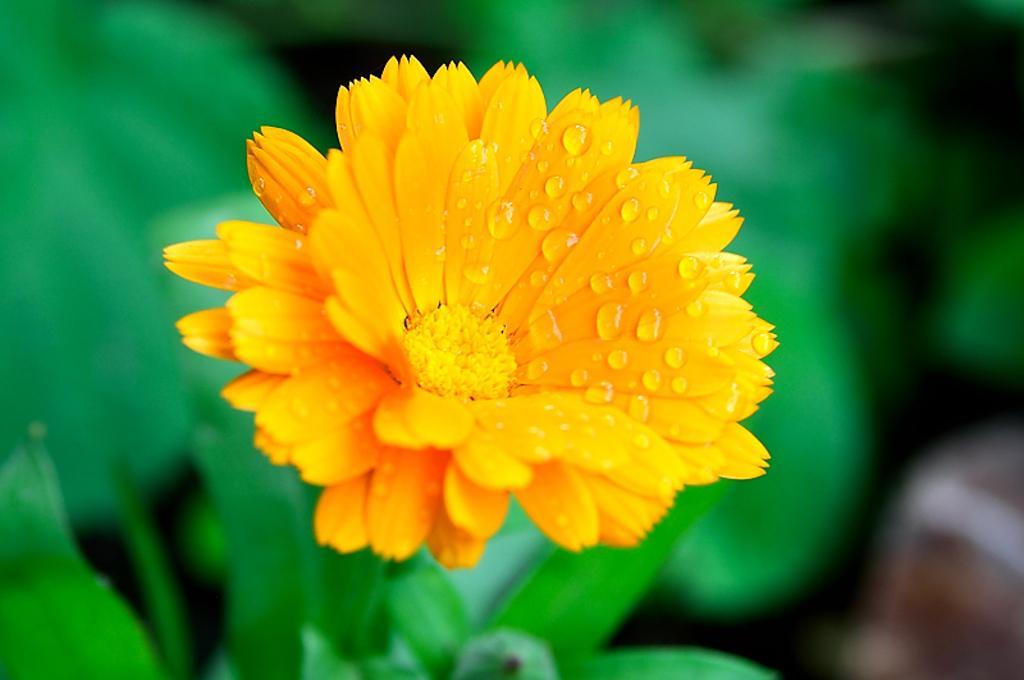Could you give a brief overview of what you see in this image? In this image in the front there is a flower and there are leaves and the background is blurry. 